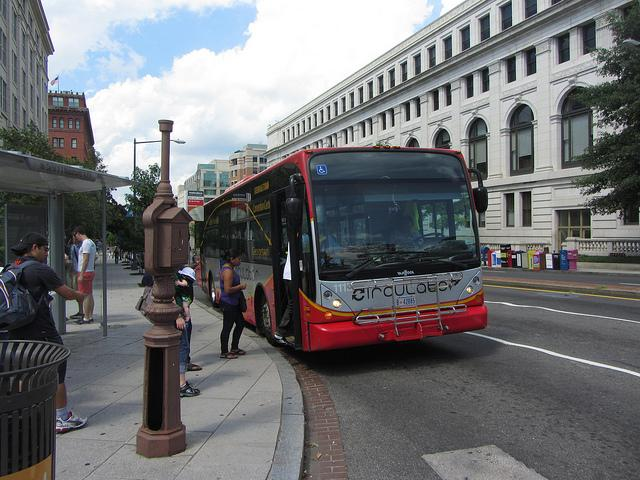What special group of people are accommodated in the bus? handicapped 